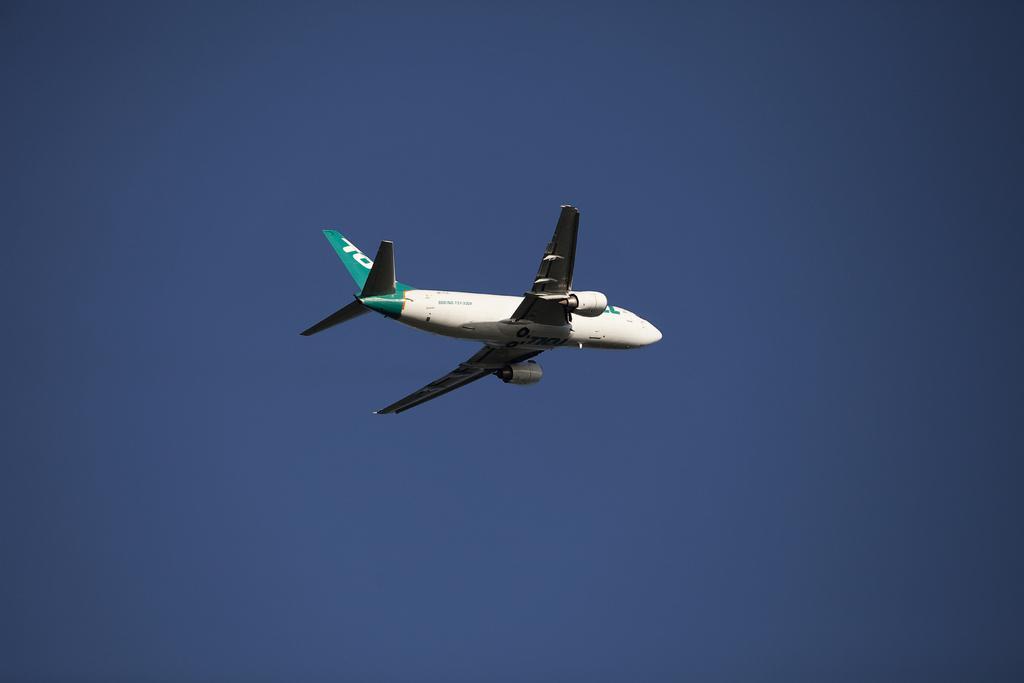Describe this image in one or two sentences. In this picture we can see an airplane flying in the air and in the background we can see the sky. 